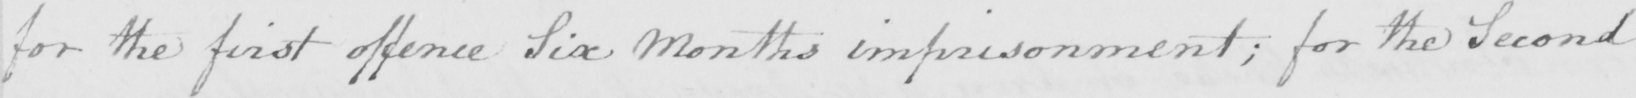Please transcribe the handwritten text in this image. for the first offence Six Months imprisonment ; for the Second 